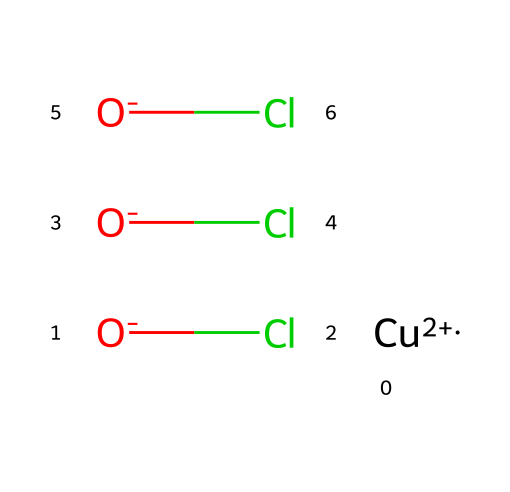What is the main metal component in copper oxychloride? The chemical structure contains the symbol "Cu," which stands for copper, indicating it is the primary metal component in copper oxychloride.
Answer: copper How many chlorine atoms are present in this chemical? In the SMILES representation, there are three instances of "Cl," indicating the presence of three chlorine atoms in the structure.
Answer: three What is the oxidation state of copper in this compound? The notation "Cu+2" indicates that copper has a +2 oxidation state in the chemical structure.
Answer: +2 How many oxygen atoms are present in copper oxychloride? The representation contains three occurrences of "O," indicating there are three oxygen atoms in the compound.
Answer: three What type of chemical reaction would copper oxychloride typically participate in as a fungicide? As a fungicide, copper oxychloride primarily functions as a protective agent against fungal growth, typically through a reaction that destroys the fungal cell wall or inhibits its growth mechanisms.
Answer: protective Which functional groups are represented in this chemical's structure? The structure does not explicitly show functional groups typically considered in organic compounds; however, the presence of chlorides and hydroxides can be thought of as functional groups contributing to its reactivity.
Answer: chlorides and hydroxides 